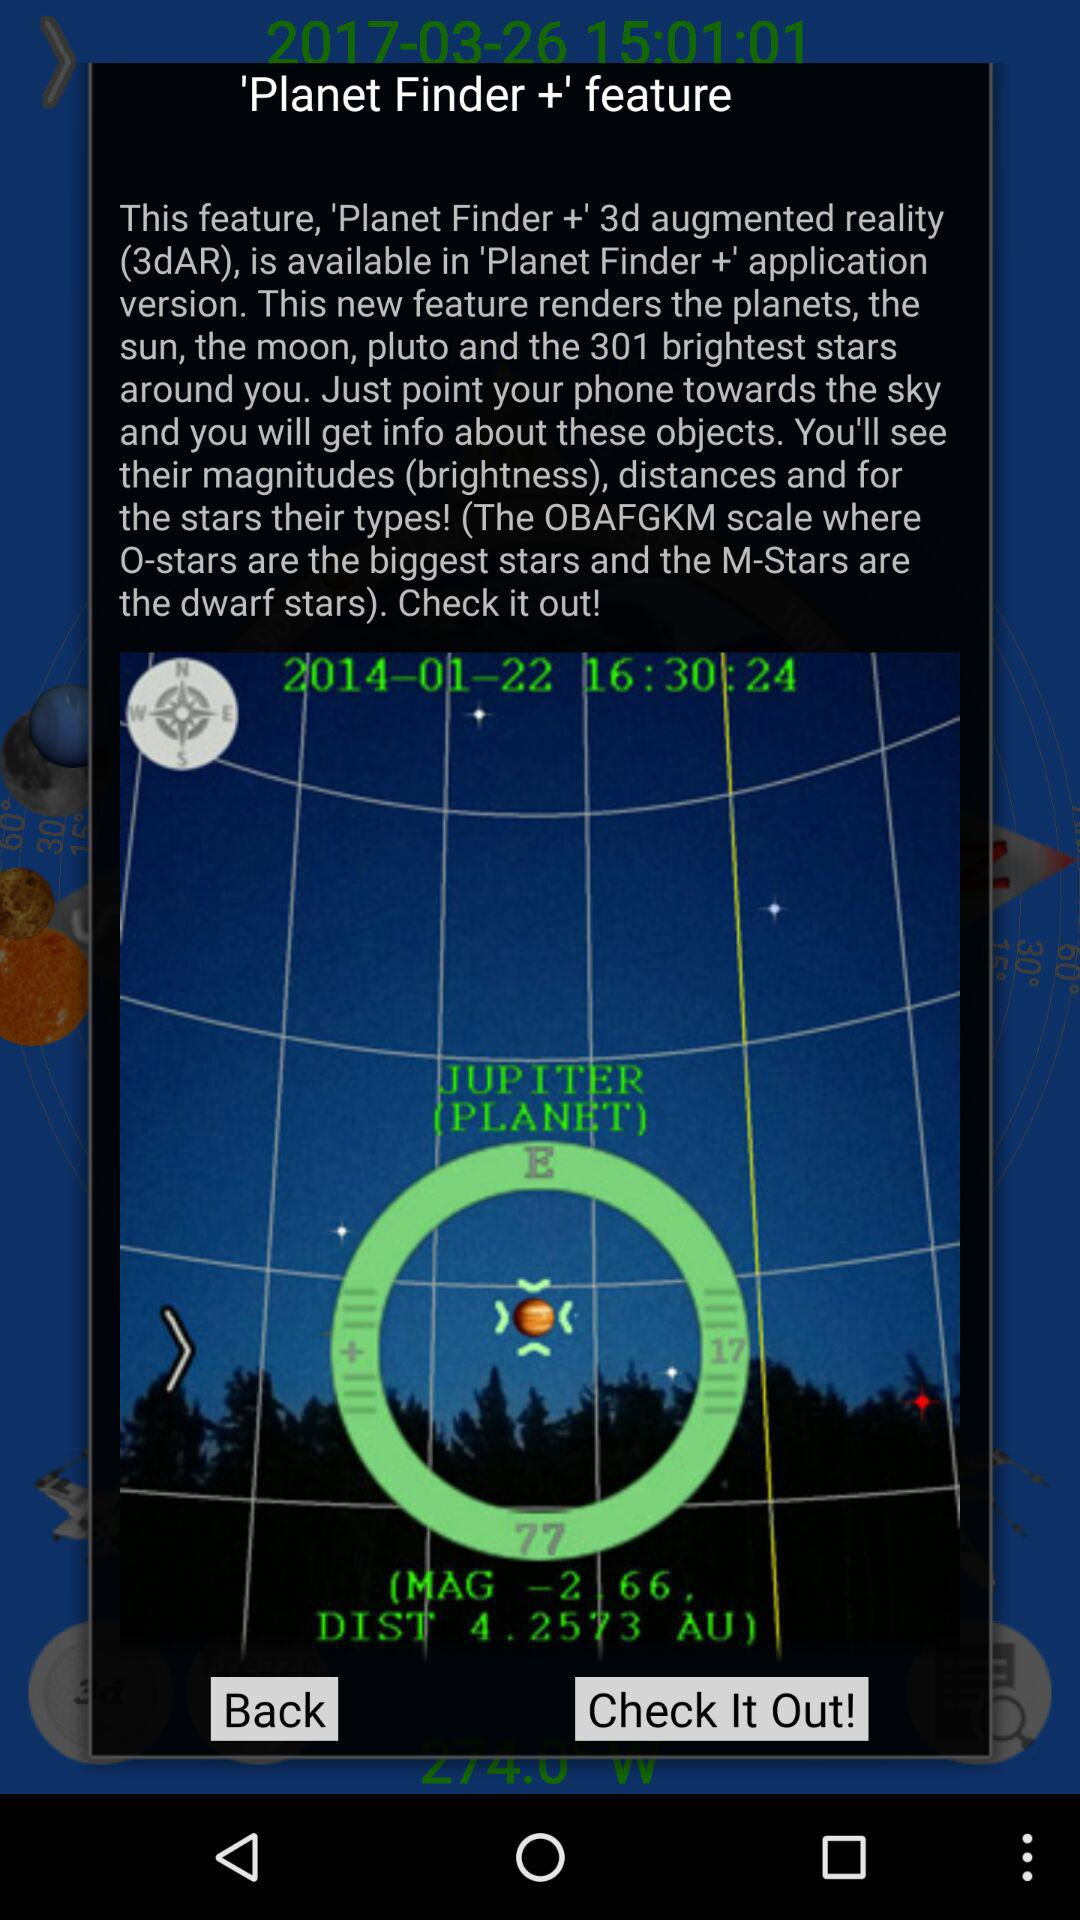How much is the given distance and magnitude? The given distance and magnitude are 2.66 and 4.2573 AU respectively. 